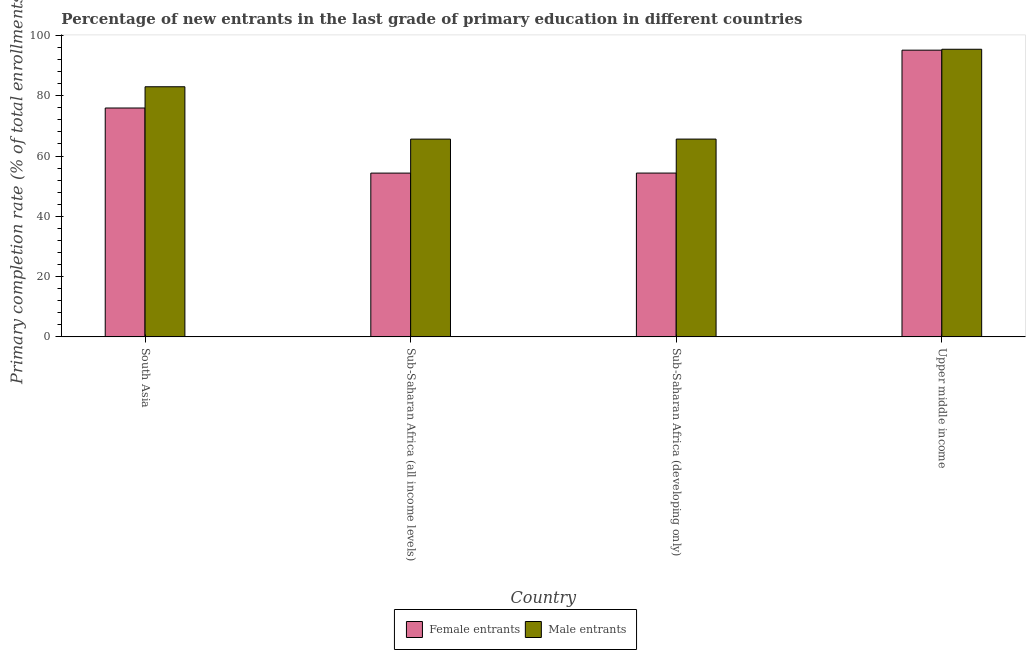How many groups of bars are there?
Keep it short and to the point. 4. How many bars are there on the 1st tick from the left?
Offer a very short reply. 2. What is the label of the 3rd group of bars from the left?
Make the answer very short. Sub-Saharan Africa (developing only). What is the primary completion rate of male entrants in Sub-Saharan Africa (all income levels)?
Make the answer very short. 65.61. Across all countries, what is the maximum primary completion rate of female entrants?
Give a very brief answer. 95.12. Across all countries, what is the minimum primary completion rate of female entrants?
Your response must be concise. 54.33. In which country was the primary completion rate of female entrants maximum?
Your response must be concise. Upper middle income. In which country was the primary completion rate of male entrants minimum?
Keep it short and to the point. Sub-Saharan Africa (all income levels). What is the total primary completion rate of male entrants in the graph?
Keep it short and to the point. 309.62. What is the difference between the primary completion rate of female entrants in Sub-Saharan Africa (all income levels) and that in Sub-Saharan Africa (developing only)?
Your answer should be compact. -0.01. What is the difference between the primary completion rate of female entrants in Upper middle income and the primary completion rate of male entrants in South Asia?
Offer a very short reply. 12.14. What is the average primary completion rate of female entrants per country?
Your answer should be very brief. 69.93. What is the difference between the primary completion rate of female entrants and primary completion rate of male entrants in Sub-Saharan Africa (all income levels)?
Your answer should be very brief. -11.27. What is the ratio of the primary completion rate of male entrants in South Asia to that in Sub-Saharan Africa (developing only)?
Provide a succinct answer. 1.26. What is the difference between the highest and the second highest primary completion rate of female entrants?
Keep it short and to the point. 19.19. What is the difference between the highest and the lowest primary completion rate of male entrants?
Your response must be concise. 29.81. Is the sum of the primary completion rate of male entrants in South Asia and Sub-Saharan Africa (developing only) greater than the maximum primary completion rate of female entrants across all countries?
Your answer should be compact. Yes. What does the 2nd bar from the left in Sub-Saharan Africa (all income levels) represents?
Your answer should be compact. Male entrants. What does the 1st bar from the right in Upper middle income represents?
Provide a succinct answer. Male entrants. How many bars are there?
Offer a very short reply. 8. Are all the bars in the graph horizontal?
Provide a short and direct response. No. What is the difference between two consecutive major ticks on the Y-axis?
Make the answer very short. 20. Are the values on the major ticks of Y-axis written in scientific E-notation?
Ensure brevity in your answer.  No. Does the graph contain grids?
Offer a very short reply. No. Where does the legend appear in the graph?
Provide a succinct answer. Bottom center. How are the legend labels stacked?
Provide a succinct answer. Horizontal. What is the title of the graph?
Provide a short and direct response. Percentage of new entrants in the last grade of primary education in different countries. What is the label or title of the Y-axis?
Give a very brief answer. Primary completion rate (% of total enrollments). What is the Primary completion rate (% of total enrollments) of Female entrants in South Asia?
Your response must be concise. 75.93. What is the Primary completion rate (% of total enrollments) in Male entrants in South Asia?
Your answer should be very brief. 82.98. What is the Primary completion rate (% of total enrollments) in Female entrants in Sub-Saharan Africa (all income levels)?
Your answer should be compact. 54.33. What is the Primary completion rate (% of total enrollments) of Male entrants in Sub-Saharan Africa (all income levels)?
Ensure brevity in your answer.  65.61. What is the Primary completion rate (% of total enrollments) in Female entrants in Sub-Saharan Africa (developing only)?
Offer a terse response. 54.34. What is the Primary completion rate (% of total enrollments) in Male entrants in Sub-Saharan Africa (developing only)?
Offer a terse response. 65.62. What is the Primary completion rate (% of total enrollments) of Female entrants in Upper middle income?
Your answer should be very brief. 95.12. What is the Primary completion rate (% of total enrollments) of Male entrants in Upper middle income?
Provide a succinct answer. 95.42. Across all countries, what is the maximum Primary completion rate (% of total enrollments) of Female entrants?
Offer a terse response. 95.12. Across all countries, what is the maximum Primary completion rate (% of total enrollments) in Male entrants?
Provide a succinct answer. 95.42. Across all countries, what is the minimum Primary completion rate (% of total enrollments) of Female entrants?
Offer a very short reply. 54.33. Across all countries, what is the minimum Primary completion rate (% of total enrollments) in Male entrants?
Your response must be concise. 65.61. What is the total Primary completion rate (% of total enrollments) of Female entrants in the graph?
Ensure brevity in your answer.  279.72. What is the total Primary completion rate (% of total enrollments) of Male entrants in the graph?
Provide a short and direct response. 309.62. What is the difference between the Primary completion rate (% of total enrollments) of Female entrants in South Asia and that in Sub-Saharan Africa (all income levels)?
Your response must be concise. 21.59. What is the difference between the Primary completion rate (% of total enrollments) of Male entrants in South Asia and that in Sub-Saharan Africa (all income levels)?
Make the answer very short. 17.37. What is the difference between the Primary completion rate (% of total enrollments) of Female entrants in South Asia and that in Sub-Saharan Africa (developing only)?
Your answer should be compact. 21.59. What is the difference between the Primary completion rate (% of total enrollments) in Male entrants in South Asia and that in Sub-Saharan Africa (developing only)?
Give a very brief answer. 17.36. What is the difference between the Primary completion rate (% of total enrollments) of Female entrants in South Asia and that in Upper middle income?
Keep it short and to the point. -19.19. What is the difference between the Primary completion rate (% of total enrollments) in Male entrants in South Asia and that in Upper middle income?
Your answer should be compact. -12.44. What is the difference between the Primary completion rate (% of total enrollments) of Female entrants in Sub-Saharan Africa (all income levels) and that in Sub-Saharan Africa (developing only)?
Keep it short and to the point. -0.01. What is the difference between the Primary completion rate (% of total enrollments) in Male entrants in Sub-Saharan Africa (all income levels) and that in Sub-Saharan Africa (developing only)?
Offer a very short reply. -0.01. What is the difference between the Primary completion rate (% of total enrollments) in Female entrants in Sub-Saharan Africa (all income levels) and that in Upper middle income?
Keep it short and to the point. -40.79. What is the difference between the Primary completion rate (% of total enrollments) in Male entrants in Sub-Saharan Africa (all income levels) and that in Upper middle income?
Give a very brief answer. -29.81. What is the difference between the Primary completion rate (% of total enrollments) in Female entrants in Sub-Saharan Africa (developing only) and that in Upper middle income?
Keep it short and to the point. -40.78. What is the difference between the Primary completion rate (% of total enrollments) of Male entrants in Sub-Saharan Africa (developing only) and that in Upper middle income?
Your answer should be very brief. -29.8. What is the difference between the Primary completion rate (% of total enrollments) in Female entrants in South Asia and the Primary completion rate (% of total enrollments) in Male entrants in Sub-Saharan Africa (all income levels)?
Provide a succinct answer. 10.32. What is the difference between the Primary completion rate (% of total enrollments) in Female entrants in South Asia and the Primary completion rate (% of total enrollments) in Male entrants in Sub-Saharan Africa (developing only)?
Ensure brevity in your answer.  10.31. What is the difference between the Primary completion rate (% of total enrollments) of Female entrants in South Asia and the Primary completion rate (% of total enrollments) of Male entrants in Upper middle income?
Offer a terse response. -19.49. What is the difference between the Primary completion rate (% of total enrollments) of Female entrants in Sub-Saharan Africa (all income levels) and the Primary completion rate (% of total enrollments) of Male entrants in Sub-Saharan Africa (developing only)?
Your answer should be very brief. -11.29. What is the difference between the Primary completion rate (% of total enrollments) in Female entrants in Sub-Saharan Africa (all income levels) and the Primary completion rate (% of total enrollments) in Male entrants in Upper middle income?
Offer a very short reply. -41.09. What is the difference between the Primary completion rate (% of total enrollments) in Female entrants in Sub-Saharan Africa (developing only) and the Primary completion rate (% of total enrollments) in Male entrants in Upper middle income?
Provide a short and direct response. -41.08. What is the average Primary completion rate (% of total enrollments) of Female entrants per country?
Ensure brevity in your answer.  69.93. What is the average Primary completion rate (% of total enrollments) of Male entrants per country?
Make the answer very short. 77.4. What is the difference between the Primary completion rate (% of total enrollments) of Female entrants and Primary completion rate (% of total enrollments) of Male entrants in South Asia?
Your answer should be compact. -7.05. What is the difference between the Primary completion rate (% of total enrollments) of Female entrants and Primary completion rate (% of total enrollments) of Male entrants in Sub-Saharan Africa (all income levels)?
Your answer should be compact. -11.27. What is the difference between the Primary completion rate (% of total enrollments) of Female entrants and Primary completion rate (% of total enrollments) of Male entrants in Sub-Saharan Africa (developing only)?
Give a very brief answer. -11.28. What is the difference between the Primary completion rate (% of total enrollments) in Female entrants and Primary completion rate (% of total enrollments) in Male entrants in Upper middle income?
Offer a terse response. -0.3. What is the ratio of the Primary completion rate (% of total enrollments) in Female entrants in South Asia to that in Sub-Saharan Africa (all income levels)?
Your response must be concise. 1.4. What is the ratio of the Primary completion rate (% of total enrollments) in Male entrants in South Asia to that in Sub-Saharan Africa (all income levels)?
Your answer should be very brief. 1.26. What is the ratio of the Primary completion rate (% of total enrollments) of Female entrants in South Asia to that in Sub-Saharan Africa (developing only)?
Your answer should be compact. 1.4. What is the ratio of the Primary completion rate (% of total enrollments) in Male entrants in South Asia to that in Sub-Saharan Africa (developing only)?
Provide a succinct answer. 1.26. What is the ratio of the Primary completion rate (% of total enrollments) in Female entrants in South Asia to that in Upper middle income?
Provide a short and direct response. 0.8. What is the ratio of the Primary completion rate (% of total enrollments) of Male entrants in South Asia to that in Upper middle income?
Your answer should be very brief. 0.87. What is the ratio of the Primary completion rate (% of total enrollments) of Male entrants in Sub-Saharan Africa (all income levels) to that in Sub-Saharan Africa (developing only)?
Provide a succinct answer. 1. What is the ratio of the Primary completion rate (% of total enrollments) in Female entrants in Sub-Saharan Africa (all income levels) to that in Upper middle income?
Keep it short and to the point. 0.57. What is the ratio of the Primary completion rate (% of total enrollments) of Male entrants in Sub-Saharan Africa (all income levels) to that in Upper middle income?
Make the answer very short. 0.69. What is the ratio of the Primary completion rate (% of total enrollments) in Female entrants in Sub-Saharan Africa (developing only) to that in Upper middle income?
Offer a very short reply. 0.57. What is the ratio of the Primary completion rate (% of total enrollments) in Male entrants in Sub-Saharan Africa (developing only) to that in Upper middle income?
Make the answer very short. 0.69. What is the difference between the highest and the second highest Primary completion rate (% of total enrollments) in Female entrants?
Offer a very short reply. 19.19. What is the difference between the highest and the second highest Primary completion rate (% of total enrollments) of Male entrants?
Provide a short and direct response. 12.44. What is the difference between the highest and the lowest Primary completion rate (% of total enrollments) in Female entrants?
Offer a very short reply. 40.79. What is the difference between the highest and the lowest Primary completion rate (% of total enrollments) in Male entrants?
Your answer should be compact. 29.81. 